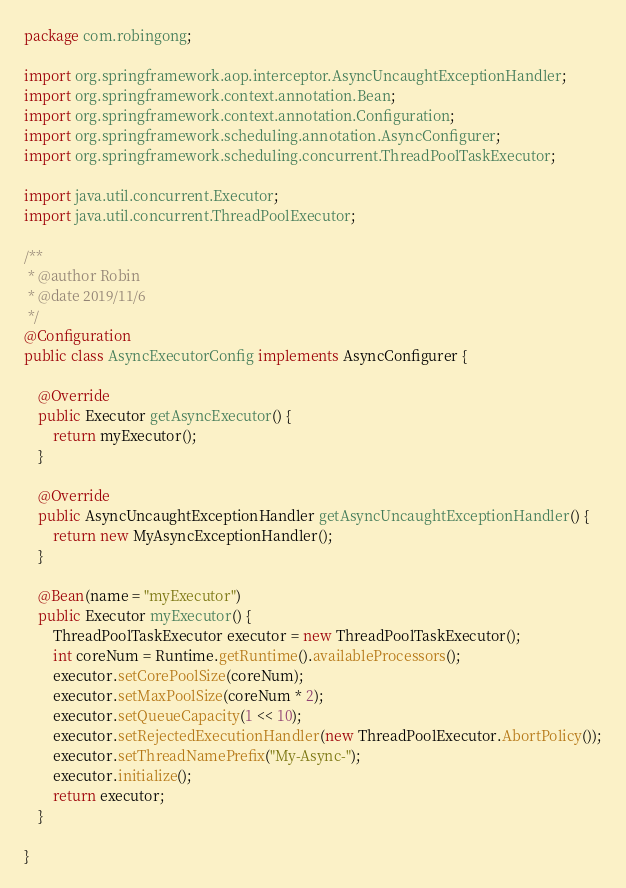<code> <loc_0><loc_0><loc_500><loc_500><_Java_>package com.robingong;

import org.springframework.aop.interceptor.AsyncUncaughtExceptionHandler;
import org.springframework.context.annotation.Bean;
import org.springframework.context.annotation.Configuration;
import org.springframework.scheduling.annotation.AsyncConfigurer;
import org.springframework.scheduling.concurrent.ThreadPoolTaskExecutor;

import java.util.concurrent.Executor;
import java.util.concurrent.ThreadPoolExecutor;

/**
 * @author Robin
 * @date 2019/11/6
 */
@Configuration
public class AsyncExecutorConfig implements AsyncConfigurer {

    @Override
    public Executor getAsyncExecutor() {
        return myExecutor();
    }

    @Override
    public AsyncUncaughtExceptionHandler getAsyncUncaughtExceptionHandler() {
        return new MyAsyncExceptionHandler();
    }

    @Bean(name = "myExecutor")
    public Executor myExecutor() {
        ThreadPoolTaskExecutor executor = new ThreadPoolTaskExecutor();
        int coreNum = Runtime.getRuntime().availableProcessors();
        executor.setCorePoolSize(coreNum);
        executor.setMaxPoolSize(coreNum * 2);
        executor.setQueueCapacity(1 << 10);
        executor.setRejectedExecutionHandler(new ThreadPoolExecutor.AbortPolicy());
        executor.setThreadNamePrefix("My-Async-");
        executor.initialize();
        return executor;
    }

}
</code> 